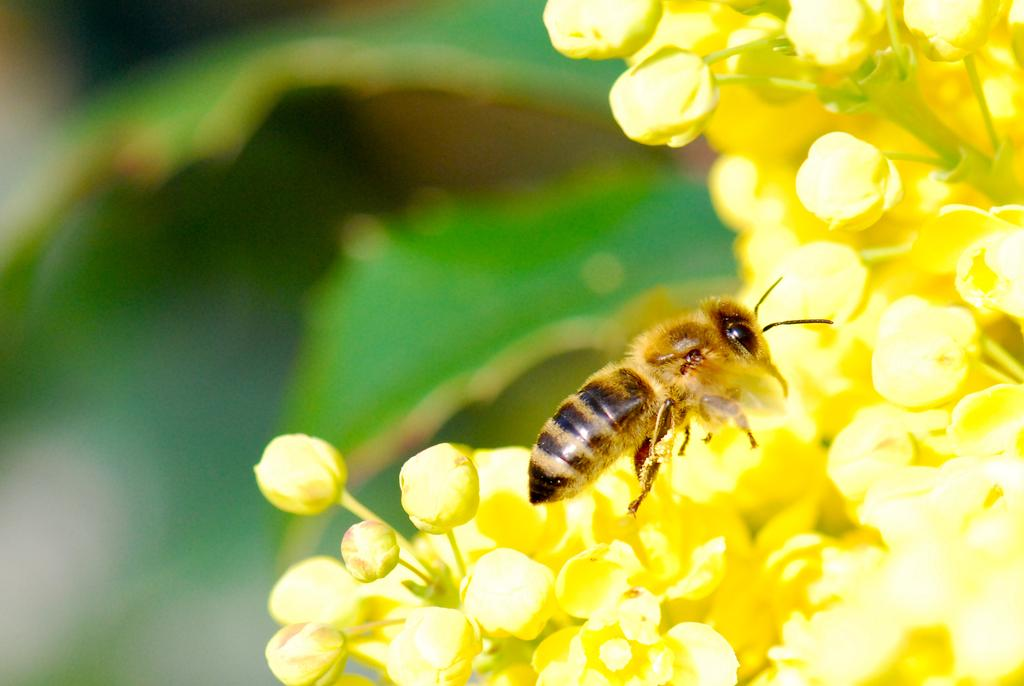What is the main subject of the image? The main subject of the image is a honey bee. Where is the honey bee located in the image? The honey bee is on yellow flowers. Can you describe the background of the image? The background of the image is blurred. What type of tin can be seen in the image? There is no tin present in the image. What is the air quality like in the image? The image does not provide information about the air quality. 